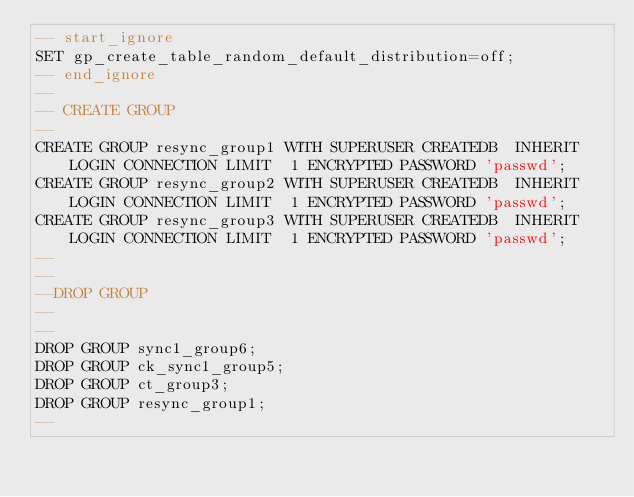<code> <loc_0><loc_0><loc_500><loc_500><_SQL_>-- start_ignore
SET gp_create_table_random_default_distribution=off;
-- end_ignore
--
-- CREATE GROUP
--
CREATE GROUP resync_group1 WITH SUPERUSER CREATEDB  INHERIT LOGIN CONNECTION LIMIT  1 ENCRYPTED PASSWORD 'passwd';
CREATE GROUP resync_group2 WITH SUPERUSER CREATEDB  INHERIT LOGIN CONNECTION LIMIT  1 ENCRYPTED PASSWORD 'passwd';
CREATE GROUP resync_group3 WITH SUPERUSER CREATEDB  INHERIT LOGIN CONNECTION LIMIT  1 ENCRYPTED PASSWORD 'passwd';
--
--
--DROP GROUP
--
--
DROP GROUP sync1_group6;
DROP GROUP ck_sync1_group5;
DROP GROUP ct_group3;
DROP GROUP resync_group1;
--
</code> 